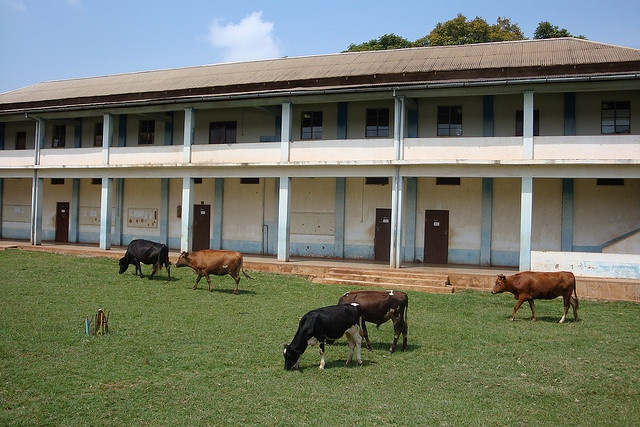Describe the objects in this image and their specific colors. I can see cow in lightblue, black, gray, and darkgreen tones, cow in lightblue, black, maroon, and brown tones, cow in lightblue, black, gray, and maroon tones, cow in lightblue, black, maroon, and gray tones, and cow in lightblue, black, gray, and darkgreen tones in this image. 